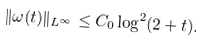Convert formula to latex. <formula><loc_0><loc_0><loc_500><loc_500>\| \omega ( t ) \| _ { L ^ { \infty } } \leq C _ { 0 } \log ^ { 2 } ( 2 + t ) .</formula> 